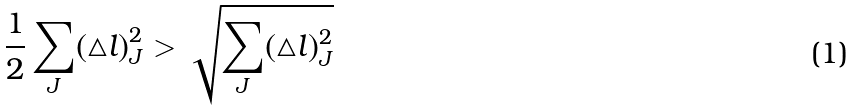Convert formula to latex. <formula><loc_0><loc_0><loc_500><loc_500>\frac { 1 } { 2 } \sum _ { J } ( \triangle l ) _ { J } ^ { 2 } > \sqrt { \sum _ { J } ( \triangle l ) _ { J } ^ { 2 } }</formula> 